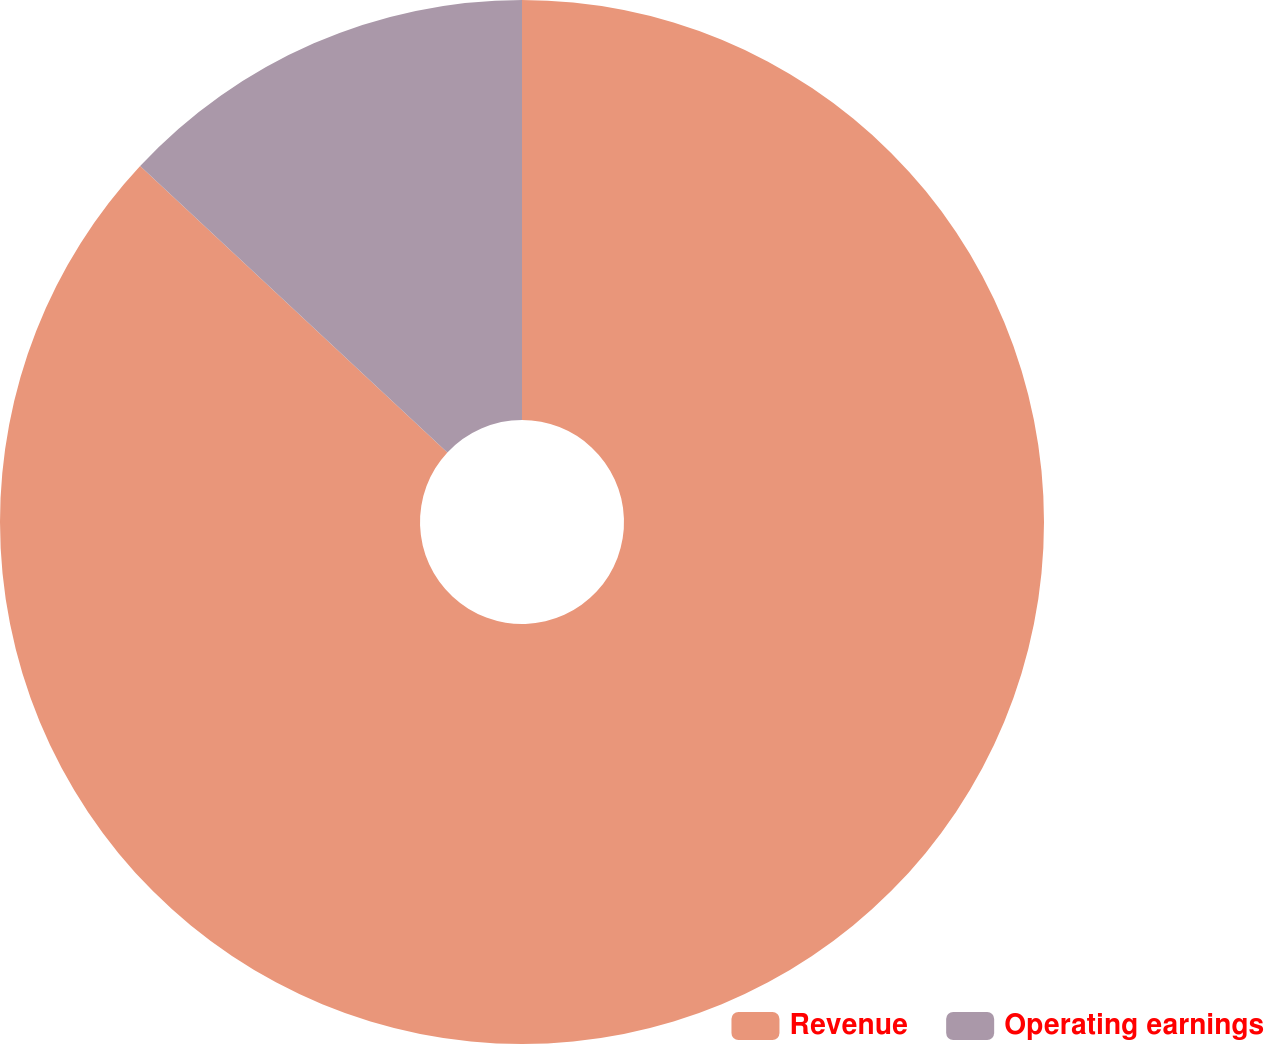<chart> <loc_0><loc_0><loc_500><loc_500><pie_chart><fcel>Revenue<fcel>Operating earnings<nl><fcel>86.94%<fcel>13.06%<nl></chart> 